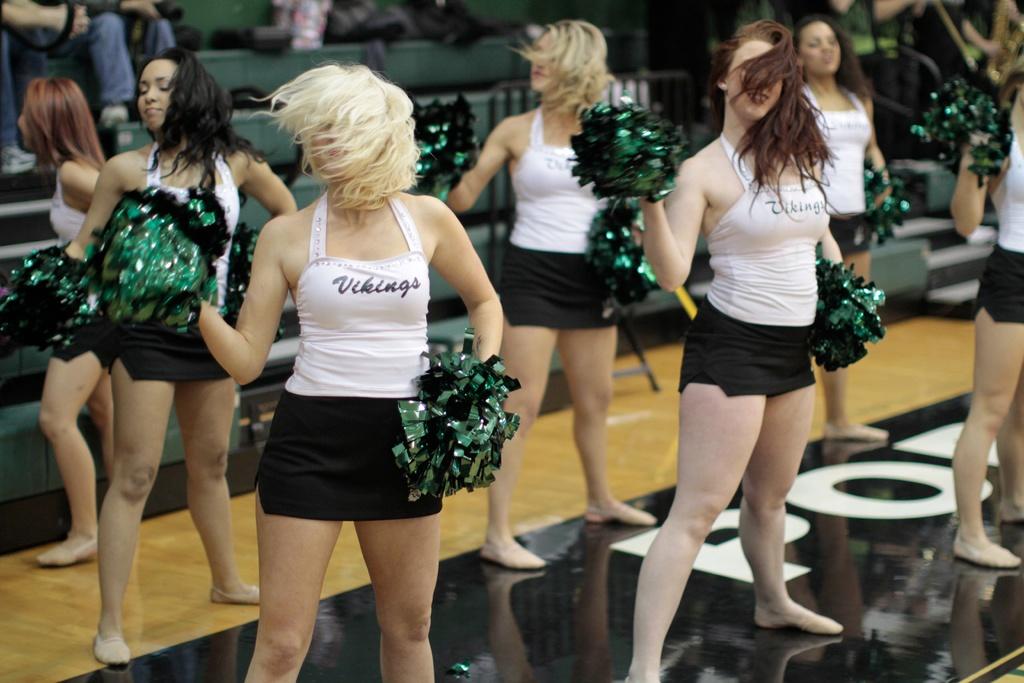What is the mascot of the cheerleaders?
Provide a succinct answer. Vikings. What team are they cheering for?
Offer a terse response. Vikings. 